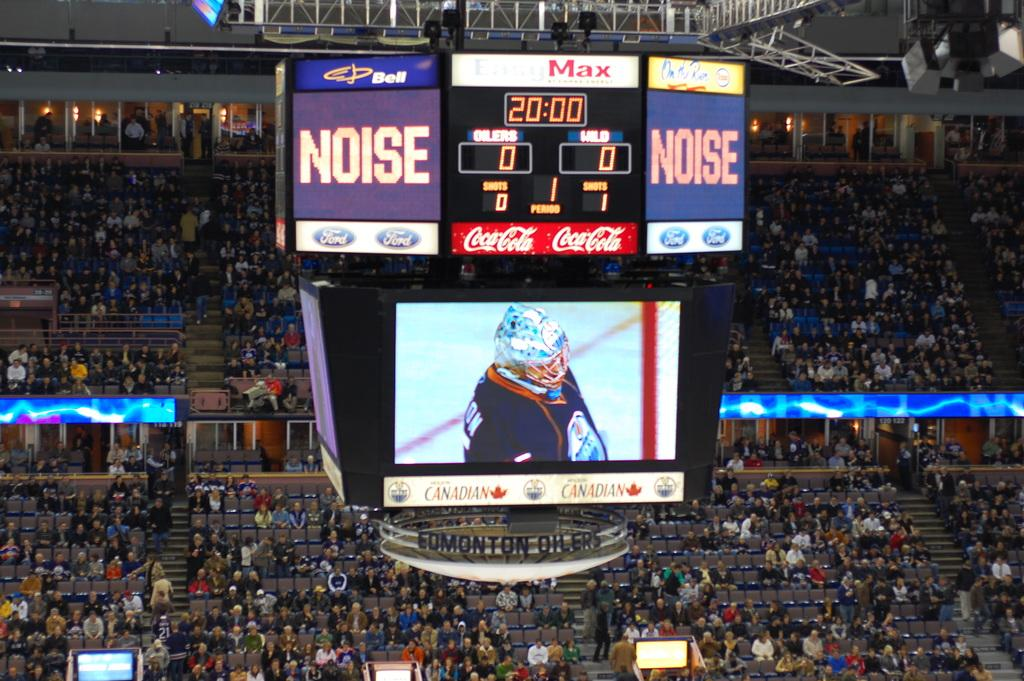<image>
Summarize the visual content of the image. A marquee in an arena that has the score 0 to 0 and NOISE lit up. 